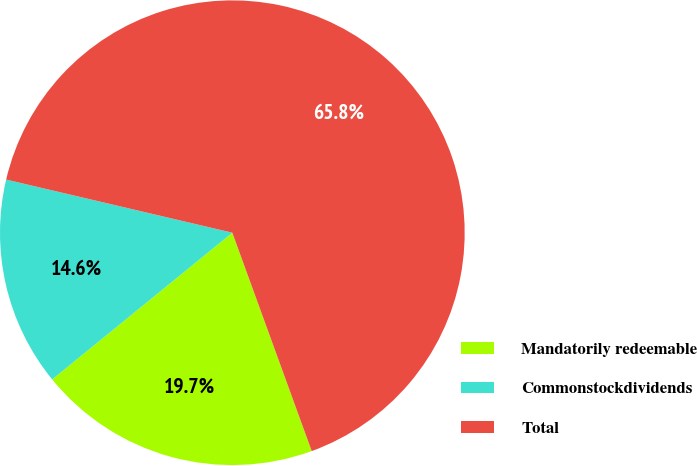Convert chart. <chart><loc_0><loc_0><loc_500><loc_500><pie_chart><fcel>Mandatorily redeemable<fcel>Commonstockdividends<fcel>Total<nl><fcel>19.67%<fcel>14.55%<fcel>65.77%<nl></chart> 